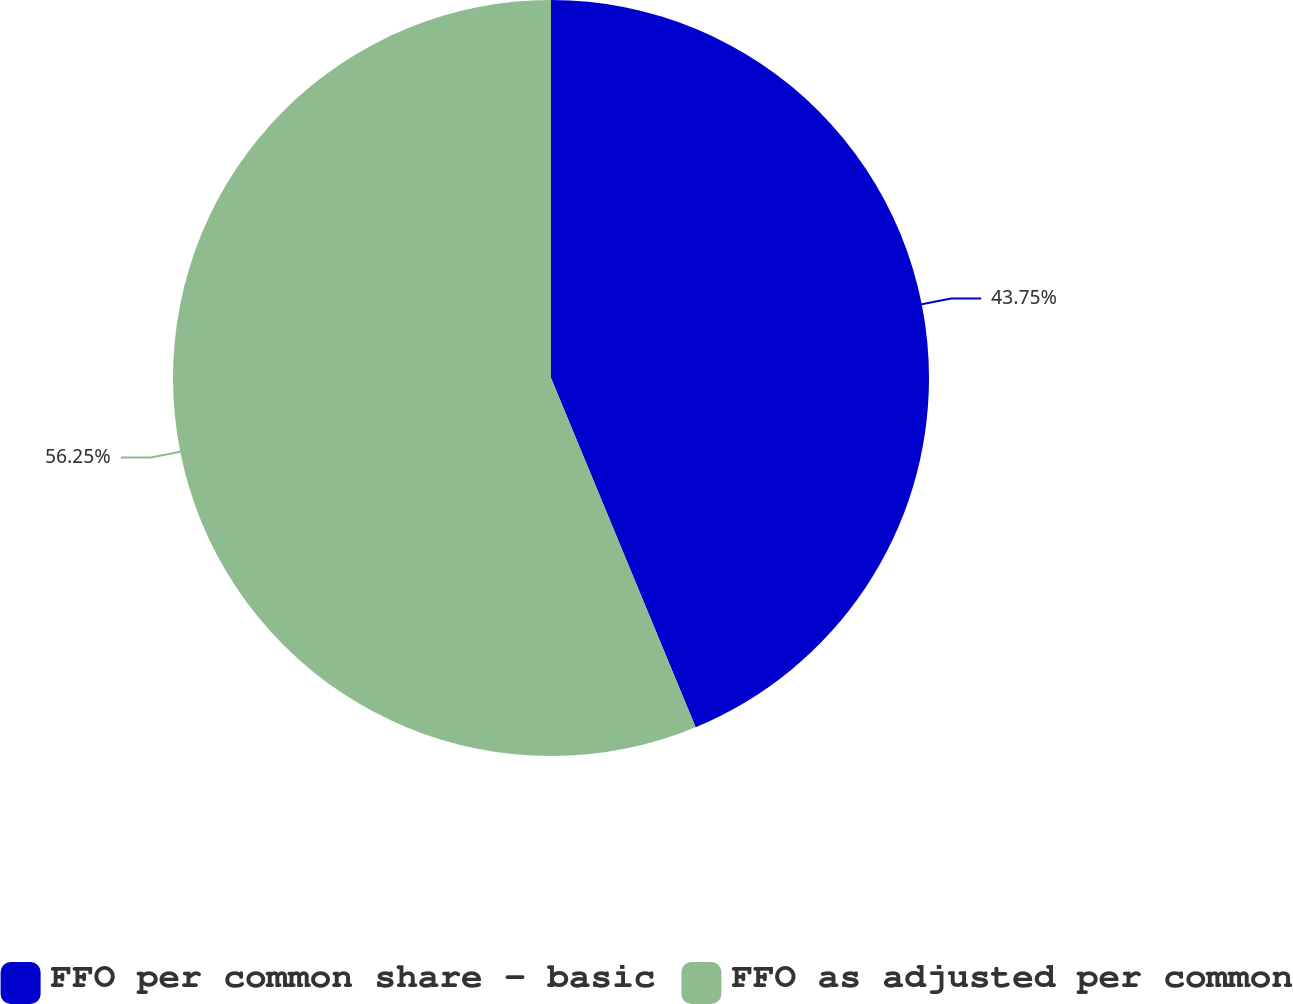<chart> <loc_0><loc_0><loc_500><loc_500><pie_chart><fcel>FFO per common share - basic<fcel>FFO as adjusted per common<nl><fcel>43.75%<fcel>56.25%<nl></chart> 